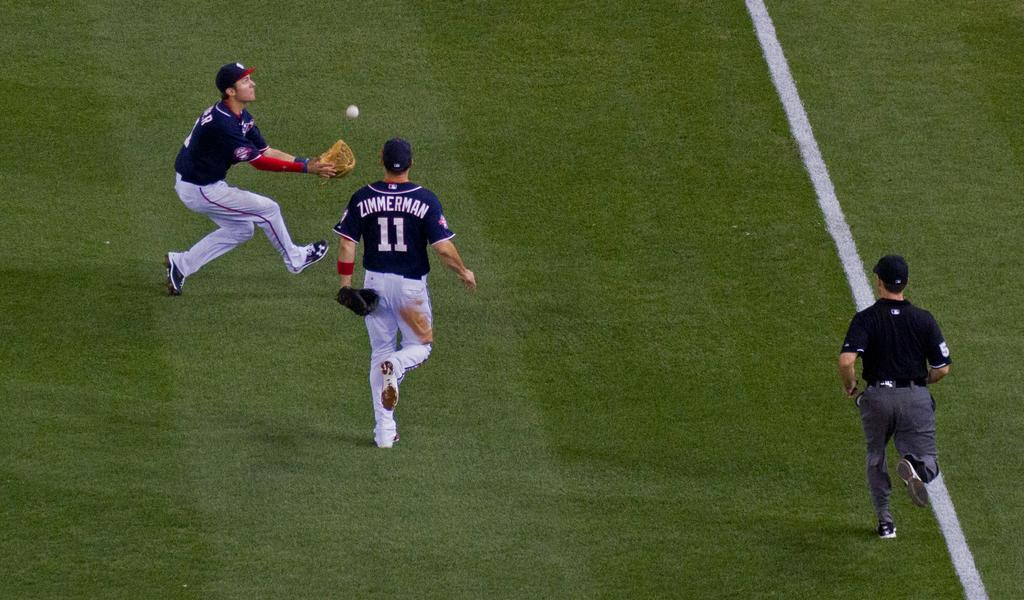Provide a one-sentence caption for the provided image. A player named Zimmerman races toward another player, who is catching the ball. 